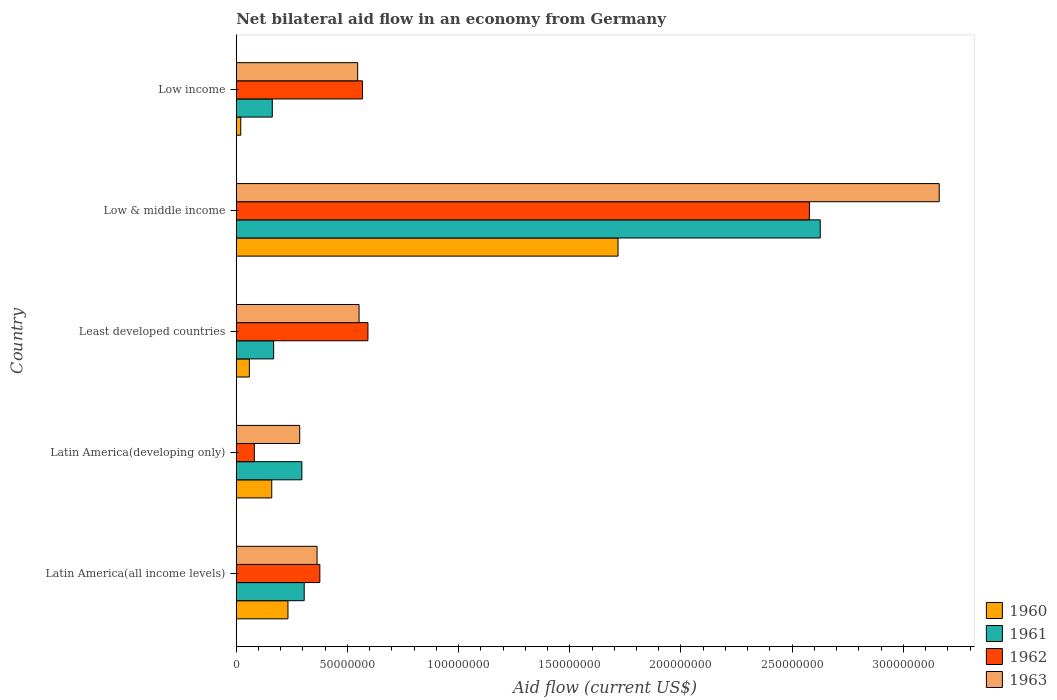How many different coloured bars are there?
Give a very brief answer. 4. How many groups of bars are there?
Make the answer very short. 5. Are the number of bars per tick equal to the number of legend labels?
Offer a terse response. Yes. How many bars are there on the 1st tick from the bottom?
Give a very brief answer. 4. What is the label of the 2nd group of bars from the top?
Your response must be concise. Low & middle income. What is the net bilateral aid flow in 1963 in Least developed countries?
Make the answer very short. 5.52e+07. Across all countries, what is the maximum net bilateral aid flow in 1961?
Make the answer very short. 2.63e+08. Across all countries, what is the minimum net bilateral aid flow in 1960?
Provide a short and direct response. 2.02e+06. In which country was the net bilateral aid flow in 1961 maximum?
Provide a succinct answer. Low & middle income. In which country was the net bilateral aid flow in 1963 minimum?
Your response must be concise. Latin America(developing only). What is the total net bilateral aid flow in 1960 in the graph?
Offer a terse response. 2.19e+08. What is the difference between the net bilateral aid flow in 1962 in Latin America(all income levels) and that in Low & middle income?
Make the answer very short. -2.20e+08. What is the difference between the net bilateral aid flow in 1960 in Least developed countries and the net bilateral aid flow in 1963 in Low & middle income?
Ensure brevity in your answer.  -3.10e+08. What is the average net bilateral aid flow in 1963 per country?
Keep it short and to the point. 9.82e+07. What is the difference between the net bilateral aid flow in 1963 and net bilateral aid flow in 1960 in Least developed countries?
Provide a short and direct response. 4.93e+07. In how many countries, is the net bilateral aid flow in 1962 greater than 110000000 US$?
Keep it short and to the point. 1. What is the ratio of the net bilateral aid flow in 1961 in Latin America(developing only) to that in Low & middle income?
Your response must be concise. 0.11. What is the difference between the highest and the second highest net bilateral aid flow in 1963?
Keep it short and to the point. 2.61e+08. What is the difference between the highest and the lowest net bilateral aid flow in 1961?
Keep it short and to the point. 2.46e+08. In how many countries, is the net bilateral aid flow in 1962 greater than the average net bilateral aid flow in 1962 taken over all countries?
Your answer should be very brief. 1. Is it the case that in every country, the sum of the net bilateral aid flow in 1960 and net bilateral aid flow in 1961 is greater than the sum of net bilateral aid flow in 1962 and net bilateral aid flow in 1963?
Your answer should be very brief. No. How many bars are there?
Ensure brevity in your answer.  20. How many countries are there in the graph?
Provide a succinct answer. 5. What is the difference between two consecutive major ticks on the X-axis?
Give a very brief answer. 5.00e+07. Does the graph contain any zero values?
Ensure brevity in your answer.  No. Where does the legend appear in the graph?
Give a very brief answer. Bottom right. How are the legend labels stacked?
Offer a very short reply. Vertical. What is the title of the graph?
Your response must be concise. Net bilateral aid flow in an economy from Germany. What is the Aid flow (current US$) in 1960 in Latin America(all income levels)?
Ensure brevity in your answer.  2.32e+07. What is the Aid flow (current US$) in 1961 in Latin America(all income levels)?
Ensure brevity in your answer.  3.06e+07. What is the Aid flow (current US$) of 1962 in Latin America(all income levels)?
Your answer should be compact. 3.76e+07. What is the Aid flow (current US$) in 1963 in Latin America(all income levels)?
Provide a succinct answer. 3.64e+07. What is the Aid flow (current US$) of 1960 in Latin America(developing only)?
Offer a terse response. 1.60e+07. What is the Aid flow (current US$) of 1961 in Latin America(developing only)?
Provide a short and direct response. 2.95e+07. What is the Aid flow (current US$) of 1962 in Latin America(developing only)?
Give a very brief answer. 8.13e+06. What is the Aid flow (current US$) in 1963 in Latin America(developing only)?
Ensure brevity in your answer.  2.85e+07. What is the Aid flow (current US$) of 1960 in Least developed countries?
Give a very brief answer. 5.90e+06. What is the Aid flow (current US$) of 1961 in Least developed countries?
Offer a very short reply. 1.68e+07. What is the Aid flow (current US$) of 1962 in Least developed countries?
Your response must be concise. 5.92e+07. What is the Aid flow (current US$) of 1963 in Least developed countries?
Offer a terse response. 5.52e+07. What is the Aid flow (current US$) in 1960 in Low & middle income?
Provide a succinct answer. 1.72e+08. What is the Aid flow (current US$) of 1961 in Low & middle income?
Give a very brief answer. 2.63e+08. What is the Aid flow (current US$) of 1962 in Low & middle income?
Your response must be concise. 2.58e+08. What is the Aid flow (current US$) of 1963 in Low & middle income?
Offer a very short reply. 3.16e+08. What is the Aid flow (current US$) of 1960 in Low income?
Provide a succinct answer. 2.02e+06. What is the Aid flow (current US$) in 1961 in Low income?
Make the answer very short. 1.62e+07. What is the Aid flow (current US$) in 1962 in Low income?
Ensure brevity in your answer.  5.68e+07. What is the Aid flow (current US$) in 1963 in Low income?
Your response must be concise. 5.46e+07. Across all countries, what is the maximum Aid flow (current US$) of 1960?
Offer a terse response. 1.72e+08. Across all countries, what is the maximum Aid flow (current US$) in 1961?
Offer a very short reply. 2.63e+08. Across all countries, what is the maximum Aid flow (current US$) in 1962?
Your answer should be compact. 2.58e+08. Across all countries, what is the maximum Aid flow (current US$) of 1963?
Offer a very short reply. 3.16e+08. Across all countries, what is the minimum Aid flow (current US$) in 1960?
Give a very brief answer. 2.02e+06. Across all countries, what is the minimum Aid flow (current US$) of 1961?
Keep it short and to the point. 1.62e+07. Across all countries, what is the minimum Aid flow (current US$) of 1962?
Offer a very short reply. 8.13e+06. Across all countries, what is the minimum Aid flow (current US$) in 1963?
Ensure brevity in your answer.  2.85e+07. What is the total Aid flow (current US$) in 1960 in the graph?
Provide a succinct answer. 2.19e+08. What is the total Aid flow (current US$) in 1961 in the graph?
Your response must be concise. 3.56e+08. What is the total Aid flow (current US$) of 1962 in the graph?
Provide a succinct answer. 4.19e+08. What is the total Aid flow (current US$) in 1963 in the graph?
Keep it short and to the point. 4.91e+08. What is the difference between the Aid flow (current US$) of 1960 in Latin America(all income levels) and that in Latin America(developing only)?
Your answer should be compact. 7.29e+06. What is the difference between the Aid flow (current US$) of 1961 in Latin America(all income levels) and that in Latin America(developing only)?
Your answer should be compact. 1.04e+06. What is the difference between the Aid flow (current US$) in 1962 in Latin America(all income levels) and that in Latin America(developing only)?
Offer a very short reply. 2.95e+07. What is the difference between the Aid flow (current US$) of 1963 in Latin America(all income levels) and that in Latin America(developing only)?
Provide a succinct answer. 7.81e+06. What is the difference between the Aid flow (current US$) in 1960 in Latin America(all income levels) and that in Least developed countries?
Ensure brevity in your answer.  1.74e+07. What is the difference between the Aid flow (current US$) in 1961 in Latin America(all income levels) and that in Least developed countries?
Offer a very short reply. 1.38e+07. What is the difference between the Aid flow (current US$) in 1962 in Latin America(all income levels) and that in Least developed countries?
Ensure brevity in your answer.  -2.16e+07. What is the difference between the Aid flow (current US$) in 1963 in Latin America(all income levels) and that in Least developed countries?
Ensure brevity in your answer.  -1.89e+07. What is the difference between the Aid flow (current US$) of 1960 in Latin America(all income levels) and that in Low & middle income?
Your answer should be very brief. -1.48e+08. What is the difference between the Aid flow (current US$) of 1961 in Latin America(all income levels) and that in Low & middle income?
Your response must be concise. -2.32e+08. What is the difference between the Aid flow (current US$) in 1962 in Latin America(all income levels) and that in Low & middle income?
Your answer should be very brief. -2.20e+08. What is the difference between the Aid flow (current US$) in 1963 in Latin America(all income levels) and that in Low & middle income?
Provide a succinct answer. -2.80e+08. What is the difference between the Aid flow (current US$) in 1960 in Latin America(all income levels) and that in Low income?
Your response must be concise. 2.12e+07. What is the difference between the Aid flow (current US$) of 1961 in Latin America(all income levels) and that in Low income?
Provide a short and direct response. 1.44e+07. What is the difference between the Aid flow (current US$) of 1962 in Latin America(all income levels) and that in Low income?
Keep it short and to the point. -1.92e+07. What is the difference between the Aid flow (current US$) of 1963 in Latin America(all income levels) and that in Low income?
Your answer should be very brief. -1.83e+07. What is the difference between the Aid flow (current US$) of 1960 in Latin America(developing only) and that in Least developed countries?
Give a very brief answer. 1.01e+07. What is the difference between the Aid flow (current US$) in 1961 in Latin America(developing only) and that in Least developed countries?
Offer a terse response. 1.27e+07. What is the difference between the Aid flow (current US$) of 1962 in Latin America(developing only) and that in Least developed countries?
Give a very brief answer. -5.11e+07. What is the difference between the Aid flow (current US$) of 1963 in Latin America(developing only) and that in Least developed countries?
Offer a very short reply. -2.67e+07. What is the difference between the Aid flow (current US$) of 1960 in Latin America(developing only) and that in Low & middle income?
Make the answer very short. -1.56e+08. What is the difference between the Aid flow (current US$) of 1961 in Latin America(developing only) and that in Low & middle income?
Offer a terse response. -2.33e+08. What is the difference between the Aid flow (current US$) of 1962 in Latin America(developing only) and that in Low & middle income?
Offer a terse response. -2.50e+08. What is the difference between the Aid flow (current US$) of 1963 in Latin America(developing only) and that in Low & middle income?
Ensure brevity in your answer.  -2.88e+08. What is the difference between the Aid flow (current US$) of 1960 in Latin America(developing only) and that in Low income?
Ensure brevity in your answer.  1.39e+07. What is the difference between the Aid flow (current US$) in 1961 in Latin America(developing only) and that in Low income?
Your answer should be very brief. 1.33e+07. What is the difference between the Aid flow (current US$) of 1962 in Latin America(developing only) and that in Low income?
Your answer should be compact. -4.86e+07. What is the difference between the Aid flow (current US$) of 1963 in Latin America(developing only) and that in Low income?
Offer a very short reply. -2.61e+07. What is the difference between the Aid flow (current US$) in 1960 in Least developed countries and that in Low & middle income?
Keep it short and to the point. -1.66e+08. What is the difference between the Aid flow (current US$) of 1961 in Least developed countries and that in Low & middle income?
Offer a very short reply. -2.46e+08. What is the difference between the Aid flow (current US$) of 1962 in Least developed countries and that in Low & middle income?
Your answer should be very brief. -1.99e+08. What is the difference between the Aid flow (current US$) in 1963 in Least developed countries and that in Low & middle income?
Your answer should be compact. -2.61e+08. What is the difference between the Aid flow (current US$) in 1960 in Least developed countries and that in Low income?
Give a very brief answer. 3.88e+06. What is the difference between the Aid flow (current US$) in 1962 in Least developed countries and that in Low income?
Give a very brief answer. 2.45e+06. What is the difference between the Aid flow (current US$) of 1963 in Least developed countries and that in Low income?
Keep it short and to the point. 6.20e+05. What is the difference between the Aid flow (current US$) in 1960 in Low & middle income and that in Low income?
Provide a succinct answer. 1.70e+08. What is the difference between the Aid flow (current US$) of 1961 in Low & middle income and that in Low income?
Your response must be concise. 2.46e+08. What is the difference between the Aid flow (current US$) of 1962 in Low & middle income and that in Low income?
Provide a short and direct response. 2.01e+08. What is the difference between the Aid flow (current US$) in 1963 in Low & middle income and that in Low income?
Offer a terse response. 2.62e+08. What is the difference between the Aid flow (current US$) in 1960 in Latin America(all income levels) and the Aid flow (current US$) in 1961 in Latin America(developing only)?
Offer a terse response. -6.27e+06. What is the difference between the Aid flow (current US$) of 1960 in Latin America(all income levels) and the Aid flow (current US$) of 1962 in Latin America(developing only)?
Provide a succinct answer. 1.51e+07. What is the difference between the Aid flow (current US$) of 1960 in Latin America(all income levels) and the Aid flow (current US$) of 1963 in Latin America(developing only)?
Keep it short and to the point. -5.29e+06. What is the difference between the Aid flow (current US$) of 1961 in Latin America(all income levels) and the Aid flow (current US$) of 1962 in Latin America(developing only)?
Keep it short and to the point. 2.24e+07. What is the difference between the Aid flow (current US$) of 1961 in Latin America(all income levels) and the Aid flow (current US$) of 1963 in Latin America(developing only)?
Keep it short and to the point. 2.02e+06. What is the difference between the Aid flow (current US$) of 1962 in Latin America(all income levels) and the Aid flow (current US$) of 1963 in Latin America(developing only)?
Provide a short and direct response. 9.05e+06. What is the difference between the Aid flow (current US$) of 1960 in Latin America(all income levels) and the Aid flow (current US$) of 1961 in Least developed countries?
Give a very brief answer. 6.44e+06. What is the difference between the Aid flow (current US$) in 1960 in Latin America(all income levels) and the Aid flow (current US$) in 1962 in Least developed countries?
Make the answer very short. -3.60e+07. What is the difference between the Aid flow (current US$) in 1960 in Latin America(all income levels) and the Aid flow (current US$) in 1963 in Least developed countries?
Make the answer very short. -3.20e+07. What is the difference between the Aid flow (current US$) in 1961 in Latin America(all income levels) and the Aid flow (current US$) in 1962 in Least developed countries?
Provide a succinct answer. -2.87e+07. What is the difference between the Aid flow (current US$) in 1961 in Latin America(all income levels) and the Aid flow (current US$) in 1963 in Least developed countries?
Provide a short and direct response. -2.47e+07. What is the difference between the Aid flow (current US$) of 1962 in Latin America(all income levels) and the Aid flow (current US$) of 1963 in Least developed countries?
Provide a short and direct response. -1.76e+07. What is the difference between the Aid flow (current US$) of 1960 in Latin America(all income levels) and the Aid flow (current US$) of 1961 in Low & middle income?
Give a very brief answer. -2.39e+08. What is the difference between the Aid flow (current US$) of 1960 in Latin America(all income levels) and the Aid flow (current US$) of 1962 in Low & middle income?
Offer a terse response. -2.34e+08. What is the difference between the Aid flow (current US$) of 1960 in Latin America(all income levels) and the Aid flow (current US$) of 1963 in Low & middle income?
Your answer should be very brief. -2.93e+08. What is the difference between the Aid flow (current US$) in 1961 in Latin America(all income levels) and the Aid flow (current US$) in 1962 in Low & middle income?
Provide a short and direct response. -2.27e+08. What is the difference between the Aid flow (current US$) of 1961 in Latin America(all income levels) and the Aid flow (current US$) of 1963 in Low & middle income?
Keep it short and to the point. -2.86e+08. What is the difference between the Aid flow (current US$) in 1962 in Latin America(all income levels) and the Aid flow (current US$) in 1963 in Low & middle income?
Give a very brief answer. -2.79e+08. What is the difference between the Aid flow (current US$) of 1960 in Latin America(all income levels) and the Aid flow (current US$) of 1961 in Low income?
Your answer should be compact. 7.05e+06. What is the difference between the Aid flow (current US$) in 1960 in Latin America(all income levels) and the Aid flow (current US$) in 1962 in Low income?
Your answer should be compact. -3.35e+07. What is the difference between the Aid flow (current US$) of 1960 in Latin America(all income levels) and the Aid flow (current US$) of 1963 in Low income?
Offer a very short reply. -3.14e+07. What is the difference between the Aid flow (current US$) of 1961 in Latin America(all income levels) and the Aid flow (current US$) of 1962 in Low income?
Offer a very short reply. -2.62e+07. What is the difference between the Aid flow (current US$) of 1961 in Latin America(all income levels) and the Aid flow (current US$) of 1963 in Low income?
Keep it short and to the point. -2.40e+07. What is the difference between the Aid flow (current US$) in 1962 in Latin America(all income levels) and the Aid flow (current US$) in 1963 in Low income?
Provide a short and direct response. -1.70e+07. What is the difference between the Aid flow (current US$) in 1960 in Latin America(developing only) and the Aid flow (current US$) in 1961 in Least developed countries?
Keep it short and to the point. -8.50e+05. What is the difference between the Aid flow (current US$) of 1960 in Latin America(developing only) and the Aid flow (current US$) of 1962 in Least developed countries?
Make the answer very short. -4.33e+07. What is the difference between the Aid flow (current US$) in 1960 in Latin America(developing only) and the Aid flow (current US$) in 1963 in Least developed countries?
Ensure brevity in your answer.  -3.93e+07. What is the difference between the Aid flow (current US$) in 1961 in Latin America(developing only) and the Aid flow (current US$) in 1962 in Least developed countries?
Offer a terse response. -2.97e+07. What is the difference between the Aid flow (current US$) in 1961 in Latin America(developing only) and the Aid flow (current US$) in 1963 in Least developed countries?
Make the answer very short. -2.57e+07. What is the difference between the Aid flow (current US$) in 1962 in Latin America(developing only) and the Aid flow (current US$) in 1963 in Least developed countries?
Give a very brief answer. -4.71e+07. What is the difference between the Aid flow (current US$) in 1960 in Latin America(developing only) and the Aid flow (current US$) in 1961 in Low & middle income?
Offer a very short reply. -2.47e+08. What is the difference between the Aid flow (current US$) in 1960 in Latin America(developing only) and the Aid flow (current US$) in 1962 in Low & middle income?
Ensure brevity in your answer.  -2.42e+08. What is the difference between the Aid flow (current US$) of 1960 in Latin America(developing only) and the Aid flow (current US$) of 1963 in Low & middle income?
Give a very brief answer. -3.00e+08. What is the difference between the Aid flow (current US$) in 1961 in Latin America(developing only) and the Aid flow (current US$) in 1962 in Low & middle income?
Your answer should be very brief. -2.28e+08. What is the difference between the Aid flow (current US$) in 1961 in Latin America(developing only) and the Aid flow (current US$) in 1963 in Low & middle income?
Your response must be concise. -2.87e+08. What is the difference between the Aid flow (current US$) in 1962 in Latin America(developing only) and the Aid flow (current US$) in 1963 in Low & middle income?
Your answer should be compact. -3.08e+08. What is the difference between the Aid flow (current US$) of 1960 in Latin America(developing only) and the Aid flow (current US$) of 1961 in Low income?
Make the answer very short. -2.40e+05. What is the difference between the Aid flow (current US$) of 1960 in Latin America(developing only) and the Aid flow (current US$) of 1962 in Low income?
Your answer should be very brief. -4.08e+07. What is the difference between the Aid flow (current US$) of 1960 in Latin America(developing only) and the Aid flow (current US$) of 1963 in Low income?
Keep it short and to the point. -3.86e+07. What is the difference between the Aid flow (current US$) of 1961 in Latin America(developing only) and the Aid flow (current US$) of 1962 in Low income?
Offer a terse response. -2.72e+07. What is the difference between the Aid flow (current US$) in 1961 in Latin America(developing only) and the Aid flow (current US$) in 1963 in Low income?
Make the answer very short. -2.51e+07. What is the difference between the Aid flow (current US$) in 1962 in Latin America(developing only) and the Aid flow (current US$) in 1963 in Low income?
Keep it short and to the point. -4.65e+07. What is the difference between the Aid flow (current US$) in 1960 in Least developed countries and the Aid flow (current US$) in 1961 in Low & middle income?
Provide a succinct answer. -2.57e+08. What is the difference between the Aid flow (current US$) in 1960 in Least developed countries and the Aid flow (current US$) in 1962 in Low & middle income?
Provide a short and direct response. -2.52e+08. What is the difference between the Aid flow (current US$) in 1960 in Least developed countries and the Aid flow (current US$) in 1963 in Low & middle income?
Make the answer very short. -3.10e+08. What is the difference between the Aid flow (current US$) of 1961 in Least developed countries and the Aid flow (current US$) of 1962 in Low & middle income?
Offer a very short reply. -2.41e+08. What is the difference between the Aid flow (current US$) in 1961 in Least developed countries and the Aid flow (current US$) in 1963 in Low & middle income?
Provide a succinct answer. -2.99e+08. What is the difference between the Aid flow (current US$) in 1962 in Least developed countries and the Aid flow (current US$) in 1963 in Low & middle income?
Provide a short and direct response. -2.57e+08. What is the difference between the Aid flow (current US$) in 1960 in Least developed countries and the Aid flow (current US$) in 1961 in Low income?
Offer a very short reply. -1.03e+07. What is the difference between the Aid flow (current US$) of 1960 in Least developed countries and the Aid flow (current US$) of 1962 in Low income?
Give a very brief answer. -5.09e+07. What is the difference between the Aid flow (current US$) in 1960 in Least developed countries and the Aid flow (current US$) in 1963 in Low income?
Make the answer very short. -4.87e+07. What is the difference between the Aid flow (current US$) of 1961 in Least developed countries and the Aid flow (current US$) of 1962 in Low income?
Provide a succinct answer. -4.00e+07. What is the difference between the Aid flow (current US$) of 1961 in Least developed countries and the Aid flow (current US$) of 1963 in Low income?
Provide a succinct answer. -3.78e+07. What is the difference between the Aid flow (current US$) in 1962 in Least developed countries and the Aid flow (current US$) in 1963 in Low income?
Provide a short and direct response. 4.61e+06. What is the difference between the Aid flow (current US$) of 1960 in Low & middle income and the Aid flow (current US$) of 1961 in Low income?
Ensure brevity in your answer.  1.55e+08. What is the difference between the Aid flow (current US$) of 1960 in Low & middle income and the Aid flow (current US$) of 1962 in Low income?
Provide a short and direct response. 1.15e+08. What is the difference between the Aid flow (current US$) of 1960 in Low & middle income and the Aid flow (current US$) of 1963 in Low income?
Your response must be concise. 1.17e+08. What is the difference between the Aid flow (current US$) in 1961 in Low & middle income and the Aid flow (current US$) in 1962 in Low income?
Give a very brief answer. 2.06e+08. What is the difference between the Aid flow (current US$) of 1961 in Low & middle income and the Aid flow (current US$) of 1963 in Low income?
Offer a terse response. 2.08e+08. What is the difference between the Aid flow (current US$) in 1962 in Low & middle income and the Aid flow (current US$) in 1963 in Low income?
Your response must be concise. 2.03e+08. What is the average Aid flow (current US$) of 1960 per country?
Ensure brevity in your answer.  4.38e+07. What is the average Aid flow (current US$) of 1961 per country?
Your response must be concise. 7.11e+07. What is the average Aid flow (current US$) in 1962 per country?
Offer a very short reply. 8.39e+07. What is the average Aid flow (current US$) in 1963 per country?
Your answer should be compact. 9.82e+07. What is the difference between the Aid flow (current US$) in 1960 and Aid flow (current US$) in 1961 in Latin America(all income levels)?
Provide a short and direct response. -7.31e+06. What is the difference between the Aid flow (current US$) in 1960 and Aid flow (current US$) in 1962 in Latin America(all income levels)?
Your answer should be compact. -1.43e+07. What is the difference between the Aid flow (current US$) in 1960 and Aid flow (current US$) in 1963 in Latin America(all income levels)?
Provide a succinct answer. -1.31e+07. What is the difference between the Aid flow (current US$) of 1961 and Aid flow (current US$) of 1962 in Latin America(all income levels)?
Your response must be concise. -7.03e+06. What is the difference between the Aid flow (current US$) in 1961 and Aid flow (current US$) in 1963 in Latin America(all income levels)?
Provide a succinct answer. -5.79e+06. What is the difference between the Aid flow (current US$) in 1962 and Aid flow (current US$) in 1963 in Latin America(all income levels)?
Provide a succinct answer. 1.24e+06. What is the difference between the Aid flow (current US$) of 1960 and Aid flow (current US$) of 1961 in Latin America(developing only)?
Offer a very short reply. -1.36e+07. What is the difference between the Aid flow (current US$) of 1960 and Aid flow (current US$) of 1962 in Latin America(developing only)?
Your response must be concise. 7.83e+06. What is the difference between the Aid flow (current US$) of 1960 and Aid flow (current US$) of 1963 in Latin America(developing only)?
Offer a terse response. -1.26e+07. What is the difference between the Aid flow (current US$) in 1961 and Aid flow (current US$) in 1962 in Latin America(developing only)?
Provide a short and direct response. 2.14e+07. What is the difference between the Aid flow (current US$) of 1961 and Aid flow (current US$) of 1963 in Latin America(developing only)?
Offer a terse response. 9.80e+05. What is the difference between the Aid flow (current US$) in 1962 and Aid flow (current US$) in 1963 in Latin America(developing only)?
Keep it short and to the point. -2.04e+07. What is the difference between the Aid flow (current US$) in 1960 and Aid flow (current US$) in 1961 in Least developed countries?
Offer a terse response. -1.09e+07. What is the difference between the Aid flow (current US$) of 1960 and Aid flow (current US$) of 1962 in Least developed countries?
Offer a very short reply. -5.33e+07. What is the difference between the Aid flow (current US$) of 1960 and Aid flow (current US$) of 1963 in Least developed countries?
Offer a very short reply. -4.93e+07. What is the difference between the Aid flow (current US$) in 1961 and Aid flow (current US$) in 1962 in Least developed countries?
Make the answer very short. -4.24e+07. What is the difference between the Aid flow (current US$) of 1961 and Aid flow (current US$) of 1963 in Least developed countries?
Make the answer very short. -3.84e+07. What is the difference between the Aid flow (current US$) of 1962 and Aid flow (current US$) of 1963 in Least developed countries?
Make the answer very short. 3.99e+06. What is the difference between the Aid flow (current US$) in 1960 and Aid flow (current US$) in 1961 in Low & middle income?
Give a very brief answer. -9.09e+07. What is the difference between the Aid flow (current US$) in 1960 and Aid flow (current US$) in 1962 in Low & middle income?
Offer a very short reply. -8.61e+07. What is the difference between the Aid flow (current US$) in 1960 and Aid flow (current US$) in 1963 in Low & middle income?
Make the answer very short. -1.44e+08. What is the difference between the Aid flow (current US$) of 1961 and Aid flow (current US$) of 1962 in Low & middle income?
Keep it short and to the point. 4.87e+06. What is the difference between the Aid flow (current US$) in 1961 and Aid flow (current US$) in 1963 in Low & middle income?
Your response must be concise. -5.35e+07. What is the difference between the Aid flow (current US$) in 1962 and Aid flow (current US$) in 1963 in Low & middle income?
Your response must be concise. -5.84e+07. What is the difference between the Aid flow (current US$) in 1960 and Aid flow (current US$) in 1961 in Low income?
Your response must be concise. -1.42e+07. What is the difference between the Aid flow (current US$) in 1960 and Aid flow (current US$) in 1962 in Low income?
Provide a short and direct response. -5.48e+07. What is the difference between the Aid flow (current US$) of 1960 and Aid flow (current US$) of 1963 in Low income?
Keep it short and to the point. -5.26e+07. What is the difference between the Aid flow (current US$) of 1961 and Aid flow (current US$) of 1962 in Low income?
Ensure brevity in your answer.  -4.06e+07. What is the difference between the Aid flow (current US$) of 1961 and Aid flow (current US$) of 1963 in Low income?
Keep it short and to the point. -3.84e+07. What is the difference between the Aid flow (current US$) in 1962 and Aid flow (current US$) in 1963 in Low income?
Offer a very short reply. 2.16e+06. What is the ratio of the Aid flow (current US$) in 1960 in Latin America(all income levels) to that in Latin America(developing only)?
Make the answer very short. 1.46. What is the ratio of the Aid flow (current US$) of 1961 in Latin America(all income levels) to that in Latin America(developing only)?
Offer a very short reply. 1.04. What is the ratio of the Aid flow (current US$) of 1962 in Latin America(all income levels) to that in Latin America(developing only)?
Make the answer very short. 4.62. What is the ratio of the Aid flow (current US$) of 1963 in Latin America(all income levels) to that in Latin America(developing only)?
Your answer should be very brief. 1.27. What is the ratio of the Aid flow (current US$) of 1960 in Latin America(all income levels) to that in Least developed countries?
Give a very brief answer. 3.94. What is the ratio of the Aid flow (current US$) in 1961 in Latin America(all income levels) to that in Least developed countries?
Your answer should be compact. 1.82. What is the ratio of the Aid flow (current US$) in 1962 in Latin America(all income levels) to that in Least developed countries?
Give a very brief answer. 0.63. What is the ratio of the Aid flow (current US$) of 1963 in Latin America(all income levels) to that in Least developed countries?
Your answer should be compact. 0.66. What is the ratio of the Aid flow (current US$) in 1960 in Latin America(all income levels) to that in Low & middle income?
Your response must be concise. 0.14. What is the ratio of the Aid flow (current US$) in 1961 in Latin America(all income levels) to that in Low & middle income?
Give a very brief answer. 0.12. What is the ratio of the Aid flow (current US$) in 1962 in Latin America(all income levels) to that in Low & middle income?
Provide a short and direct response. 0.15. What is the ratio of the Aid flow (current US$) in 1963 in Latin America(all income levels) to that in Low & middle income?
Provide a short and direct response. 0.12. What is the ratio of the Aid flow (current US$) of 1960 in Latin America(all income levels) to that in Low income?
Provide a succinct answer. 11.51. What is the ratio of the Aid flow (current US$) in 1961 in Latin America(all income levels) to that in Low income?
Offer a very short reply. 1.89. What is the ratio of the Aid flow (current US$) of 1962 in Latin America(all income levels) to that in Low income?
Offer a very short reply. 0.66. What is the ratio of the Aid flow (current US$) of 1963 in Latin America(all income levels) to that in Low income?
Your answer should be very brief. 0.67. What is the ratio of the Aid flow (current US$) of 1960 in Latin America(developing only) to that in Least developed countries?
Keep it short and to the point. 2.71. What is the ratio of the Aid flow (current US$) in 1961 in Latin America(developing only) to that in Least developed countries?
Make the answer very short. 1.76. What is the ratio of the Aid flow (current US$) of 1962 in Latin America(developing only) to that in Least developed countries?
Make the answer very short. 0.14. What is the ratio of the Aid flow (current US$) of 1963 in Latin America(developing only) to that in Least developed countries?
Your answer should be very brief. 0.52. What is the ratio of the Aid flow (current US$) in 1960 in Latin America(developing only) to that in Low & middle income?
Make the answer very short. 0.09. What is the ratio of the Aid flow (current US$) of 1961 in Latin America(developing only) to that in Low & middle income?
Offer a very short reply. 0.11. What is the ratio of the Aid flow (current US$) in 1962 in Latin America(developing only) to that in Low & middle income?
Your answer should be compact. 0.03. What is the ratio of the Aid flow (current US$) of 1963 in Latin America(developing only) to that in Low & middle income?
Give a very brief answer. 0.09. What is the ratio of the Aid flow (current US$) of 1960 in Latin America(developing only) to that in Low income?
Make the answer very short. 7.9. What is the ratio of the Aid flow (current US$) in 1961 in Latin America(developing only) to that in Low income?
Offer a terse response. 1.82. What is the ratio of the Aid flow (current US$) of 1962 in Latin America(developing only) to that in Low income?
Offer a terse response. 0.14. What is the ratio of the Aid flow (current US$) in 1963 in Latin America(developing only) to that in Low income?
Your answer should be compact. 0.52. What is the ratio of the Aid flow (current US$) of 1960 in Least developed countries to that in Low & middle income?
Offer a terse response. 0.03. What is the ratio of the Aid flow (current US$) in 1961 in Least developed countries to that in Low & middle income?
Ensure brevity in your answer.  0.06. What is the ratio of the Aid flow (current US$) of 1962 in Least developed countries to that in Low & middle income?
Ensure brevity in your answer.  0.23. What is the ratio of the Aid flow (current US$) of 1963 in Least developed countries to that in Low & middle income?
Your response must be concise. 0.17. What is the ratio of the Aid flow (current US$) of 1960 in Least developed countries to that in Low income?
Your answer should be compact. 2.92. What is the ratio of the Aid flow (current US$) in 1961 in Least developed countries to that in Low income?
Provide a succinct answer. 1.04. What is the ratio of the Aid flow (current US$) of 1962 in Least developed countries to that in Low income?
Offer a terse response. 1.04. What is the ratio of the Aid flow (current US$) in 1963 in Least developed countries to that in Low income?
Ensure brevity in your answer.  1.01. What is the ratio of the Aid flow (current US$) in 1960 in Low & middle income to that in Low income?
Offer a terse response. 85. What is the ratio of the Aid flow (current US$) in 1961 in Low & middle income to that in Low income?
Offer a terse response. 16.21. What is the ratio of the Aid flow (current US$) of 1962 in Low & middle income to that in Low income?
Ensure brevity in your answer.  4.54. What is the ratio of the Aid flow (current US$) in 1963 in Low & middle income to that in Low income?
Offer a very short reply. 5.79. What is the difference between the highest and the second highest Aid flow (current US$) in 1960?
Provide a succinct answer. 1.48e+08. What is the difference between the highest and the second highest Aid flow (current US$) of 1961?
Provide a short and direct response. 2.32e+08. What is the difference between the highest and the second highest Aid flow (current US$) in 1962?
Your response must be concise. 1.99e+08. What is the difference between the highest and the second highest Aid flow (current US$) in 1963?
Your answer should be compact. 2.61e+08. What is the difference between the highest and the lowest Aid flow (current US$) of 1960?
Your answer should be compact. 1.70e+08. What is the difference between the highest and the lowest Aid flow (current US$) of 1961?
Give a very brief answer. 2.46e+08. What is the difference between the highest and the lowest Aid flow (current US$) of 1962?
Offer a terse response. 2.50e+08. What is the difference between the highest and the lowest Aid flow (current US$) of 1963?
Give a very brief answer. 2.88e+08. 